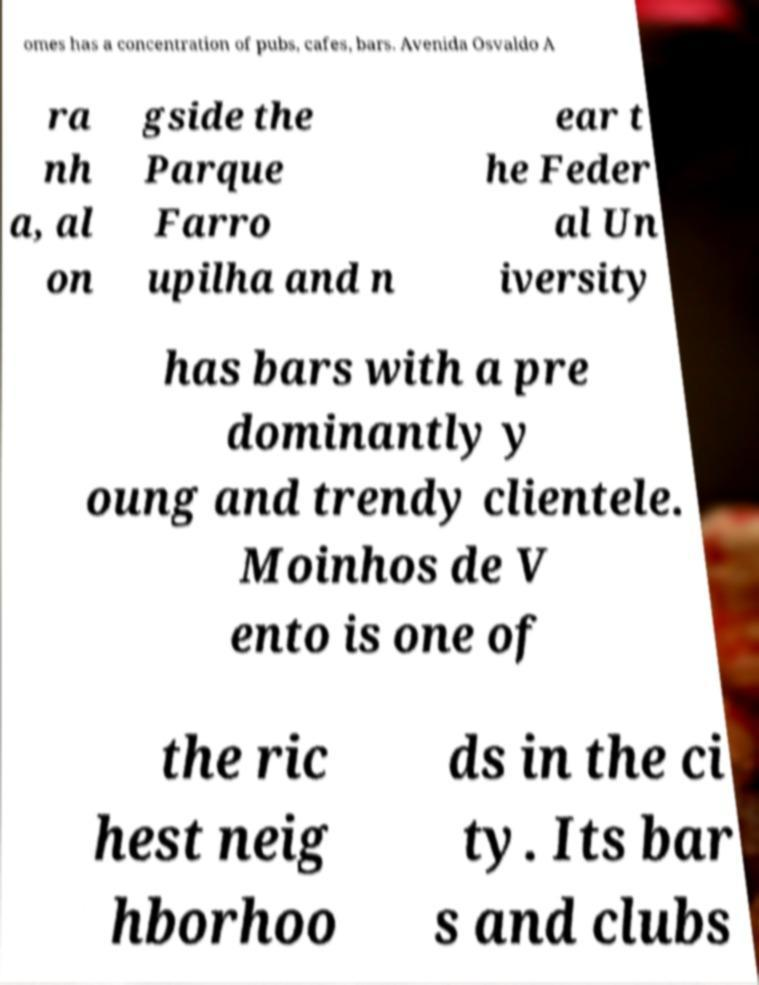Could you extract and type out the text from this image? omes has a concentration of pubs, cafes, bars. Avenida Osvaldo A ra nh a, al on gside the Parque Farro upilha and n ear t he Feder al Un iversity has bars with a pre dominantly y oung and trendy clientele. Moinhos de V ento is one of the ric hest neig hborhoo ds in the ci ty. Its bar s and clubs 